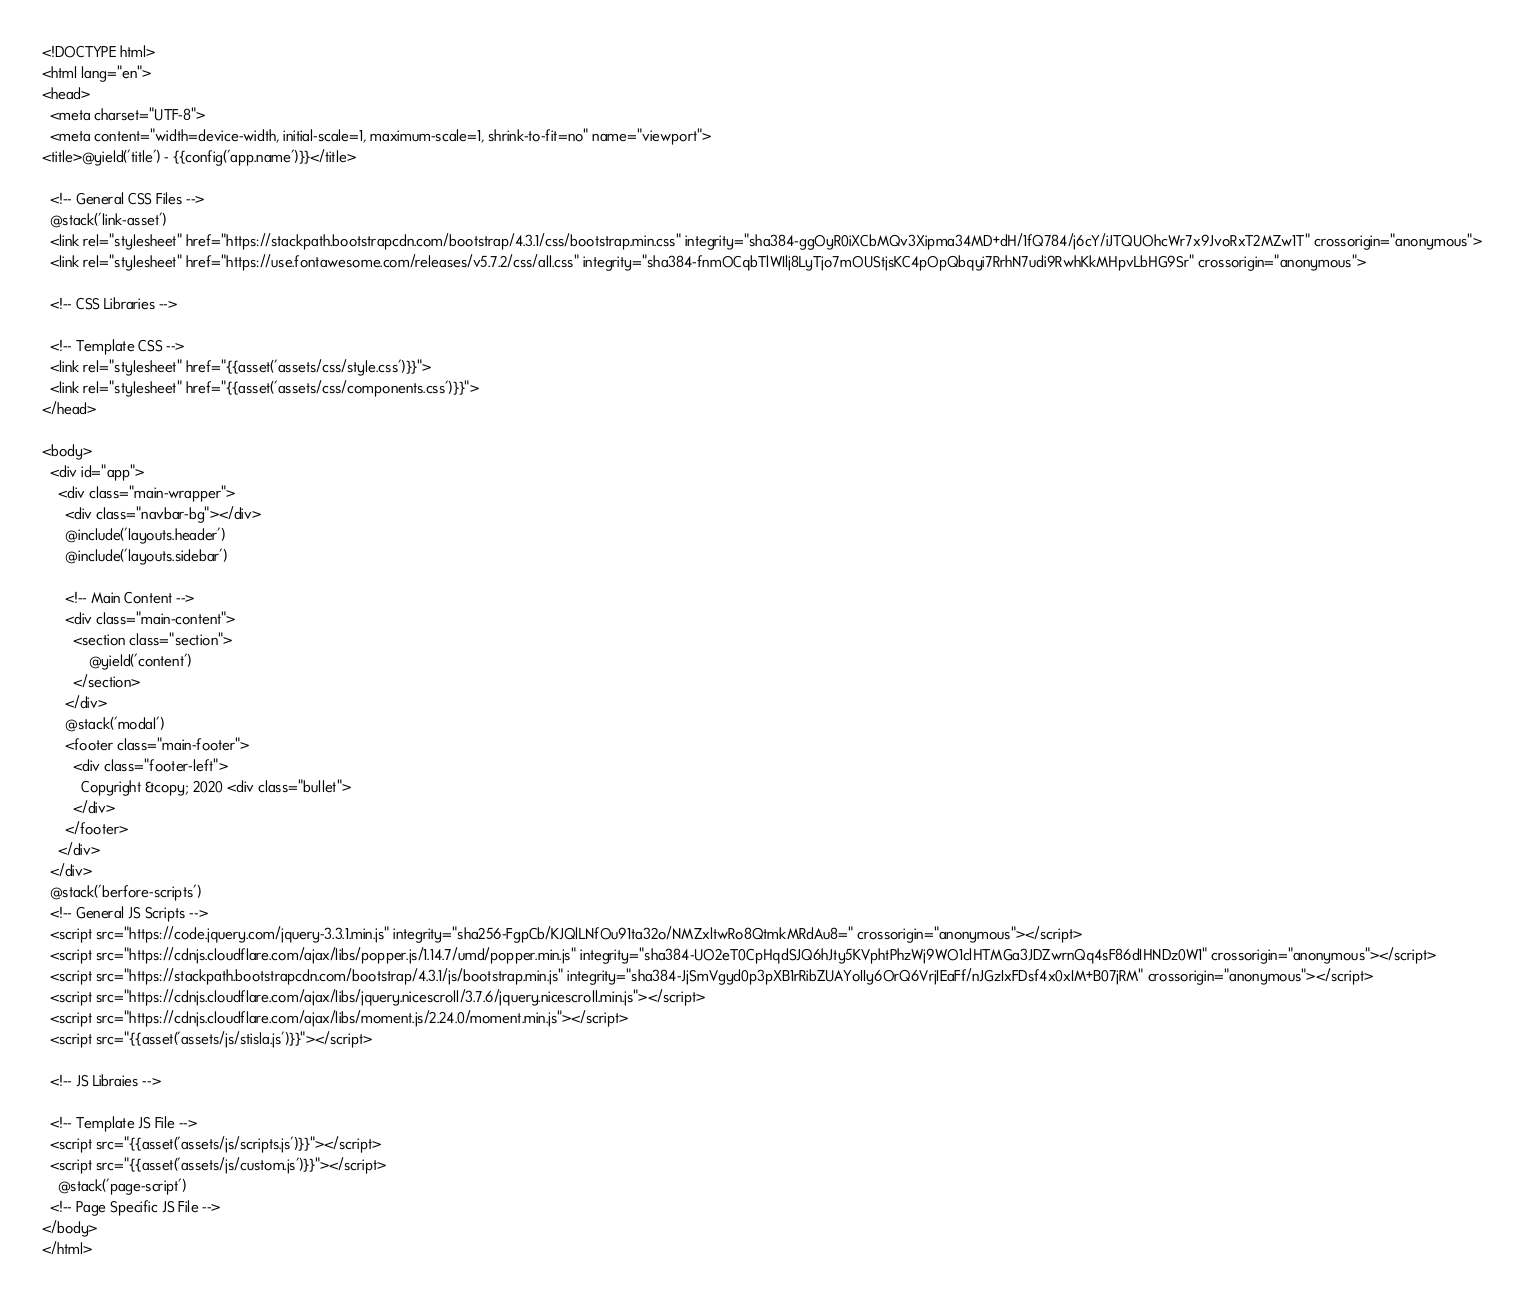Convert code to text. <code><loc_0><loc_0><loc_500><loc_500><_PHP_><!DOCTYPE html>
<html lang="en">
<head>
  <meta charset="UTF-8">
  <meta content="width=device-width, initial-scale=1, maximum-scale=1, shrink-to-fit=no" name="viewport">
<title>@yield('title') - {{config('app.name')}}</title>

  <!-- General CSS Files -->
  @stack('link-asset')
  <link rel="stylesheet" href="https://stackpath.bootstrapcdn.com/bootstrap/4.3.1/css/bootstrap.min.css" integrity="sha384-ggOyR0iXCbMQv3Xipma34MD+dH/1fQ784/j6cY/iJTQUOhcWr7x9JvoRxT2MZw1T" crossorigin="anonymous">
  <link rel="stylesheet" href="https://use.fontawesome.com/releases/v5.7.2/css/all.css" integrity="sha384-fnmOCqbTlWIlj8LyTjo7mOUStjsKC4pOpQbqyi7RrhN7udi9RwhKkMHpvLbHG9Sr" crossorigin="anonymous">

  <!-- CSS Libraries -->

  <!-- Template CSS -->
  <link rel="stylesheet" href="{{asset('assets/css/style.css')}}">
  <link rel="stylesheet" href="{{asset('assets/css/components.css')}}">
</head>

<body>
  <div id="app">
    <div class="main-wrapper">
      <div class="navbar-bg"></div>
      @include('layouts.header')
      @include('layouts.sidebar')

      <!-- Main Content -->
      <div class="main-content">
        <section class="section">
            @yield('content')
        </section>
      </div>
      @stack('modal')
      <footer class="main-footer">
        <div class="footer-left">
          Copyright &copy; 2020 <div class="bullet">
        </div>
      </footer>
    </div>
  </div>
  @stack('berfore-scripts')
  <!-- General JS Scripts -->
  <script src="https://code.jquery.com/jquery-3.3.1.min.js" integrity="sha256-FgpCb/KJQlLNfOu91ta32o/NMZxltwRo8QtmkMRdAu8=" crossorigin="anonymous"></script>
  <script src="https://cdnjs.cloudflare.com/ajax/libs/popper.js/1.14.7/umd/popper.min.js" integrity="sha384-UO2eT0CpHqdSJQ6hJty5KVphtPhzWj9WO1clHTMGa3JDZwrnQq4sF86dIHNDz0W1" crossorigin="anonymous"></script>
  <script src="https://stackpath.bootstrapcdn.com/bootstrap/4.3.1/js/bootstrap.min.js" integrity="sha384-JjSmVgyd0p3pXB1rRibZUAYoIIy6OrQ6VrjIEaFf/nJGzIxFDsf4x0xIM+B07jRM" crossorigin="anonymous"></script>
  <script src="https://cdnjs.cloudflare.com/ajax/libs/jquery.nicescroll/3.7.6/jquery.nicescroll.min.js"></script>
  <script src="https://cdnjs.cloudflare.com/ajax/libs/moment.js/2.24.0/moment.min.js"></script>
  <script src="{{asset('assets/js/stisla.js')}}"></script>

  <!-- JS Libraies -->

  <!-- Template JS File -->
  <script src="{{asset('assets/js/scripts.js')}}"></script>
  <script src="{{asset('assets/js/custom.js')}}"></script>
    @stack('page-script')
  <!-- Page Specific JS File -->
</body>
</html>
</code> 